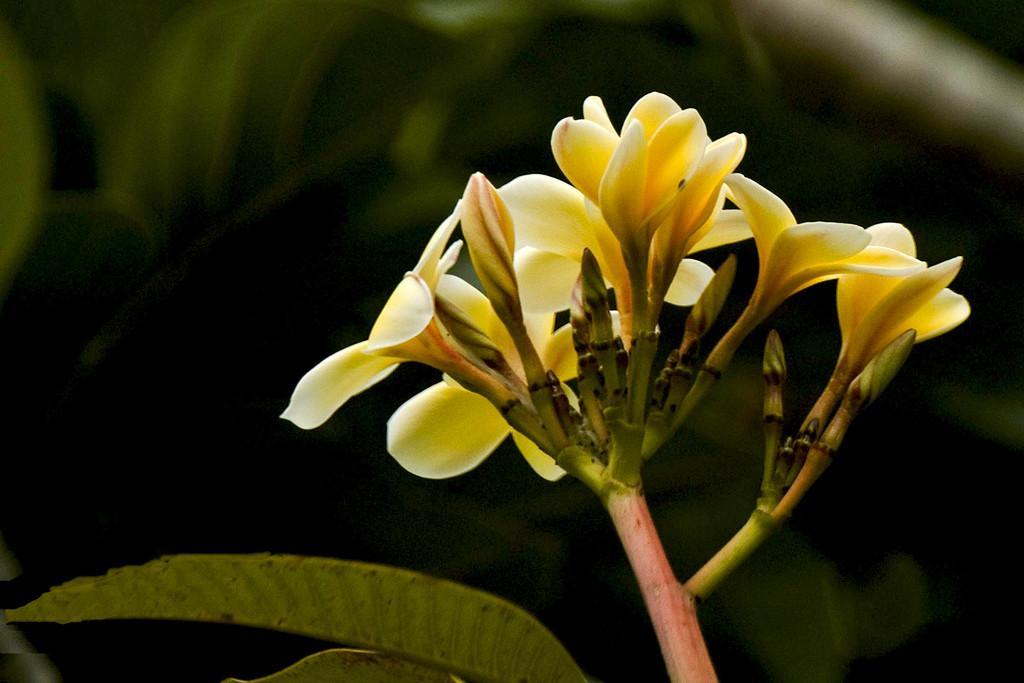Can you describe this image briefly? In this image I can see a part of a plant along with the flowers, buds and leaves. The background is blurred. 